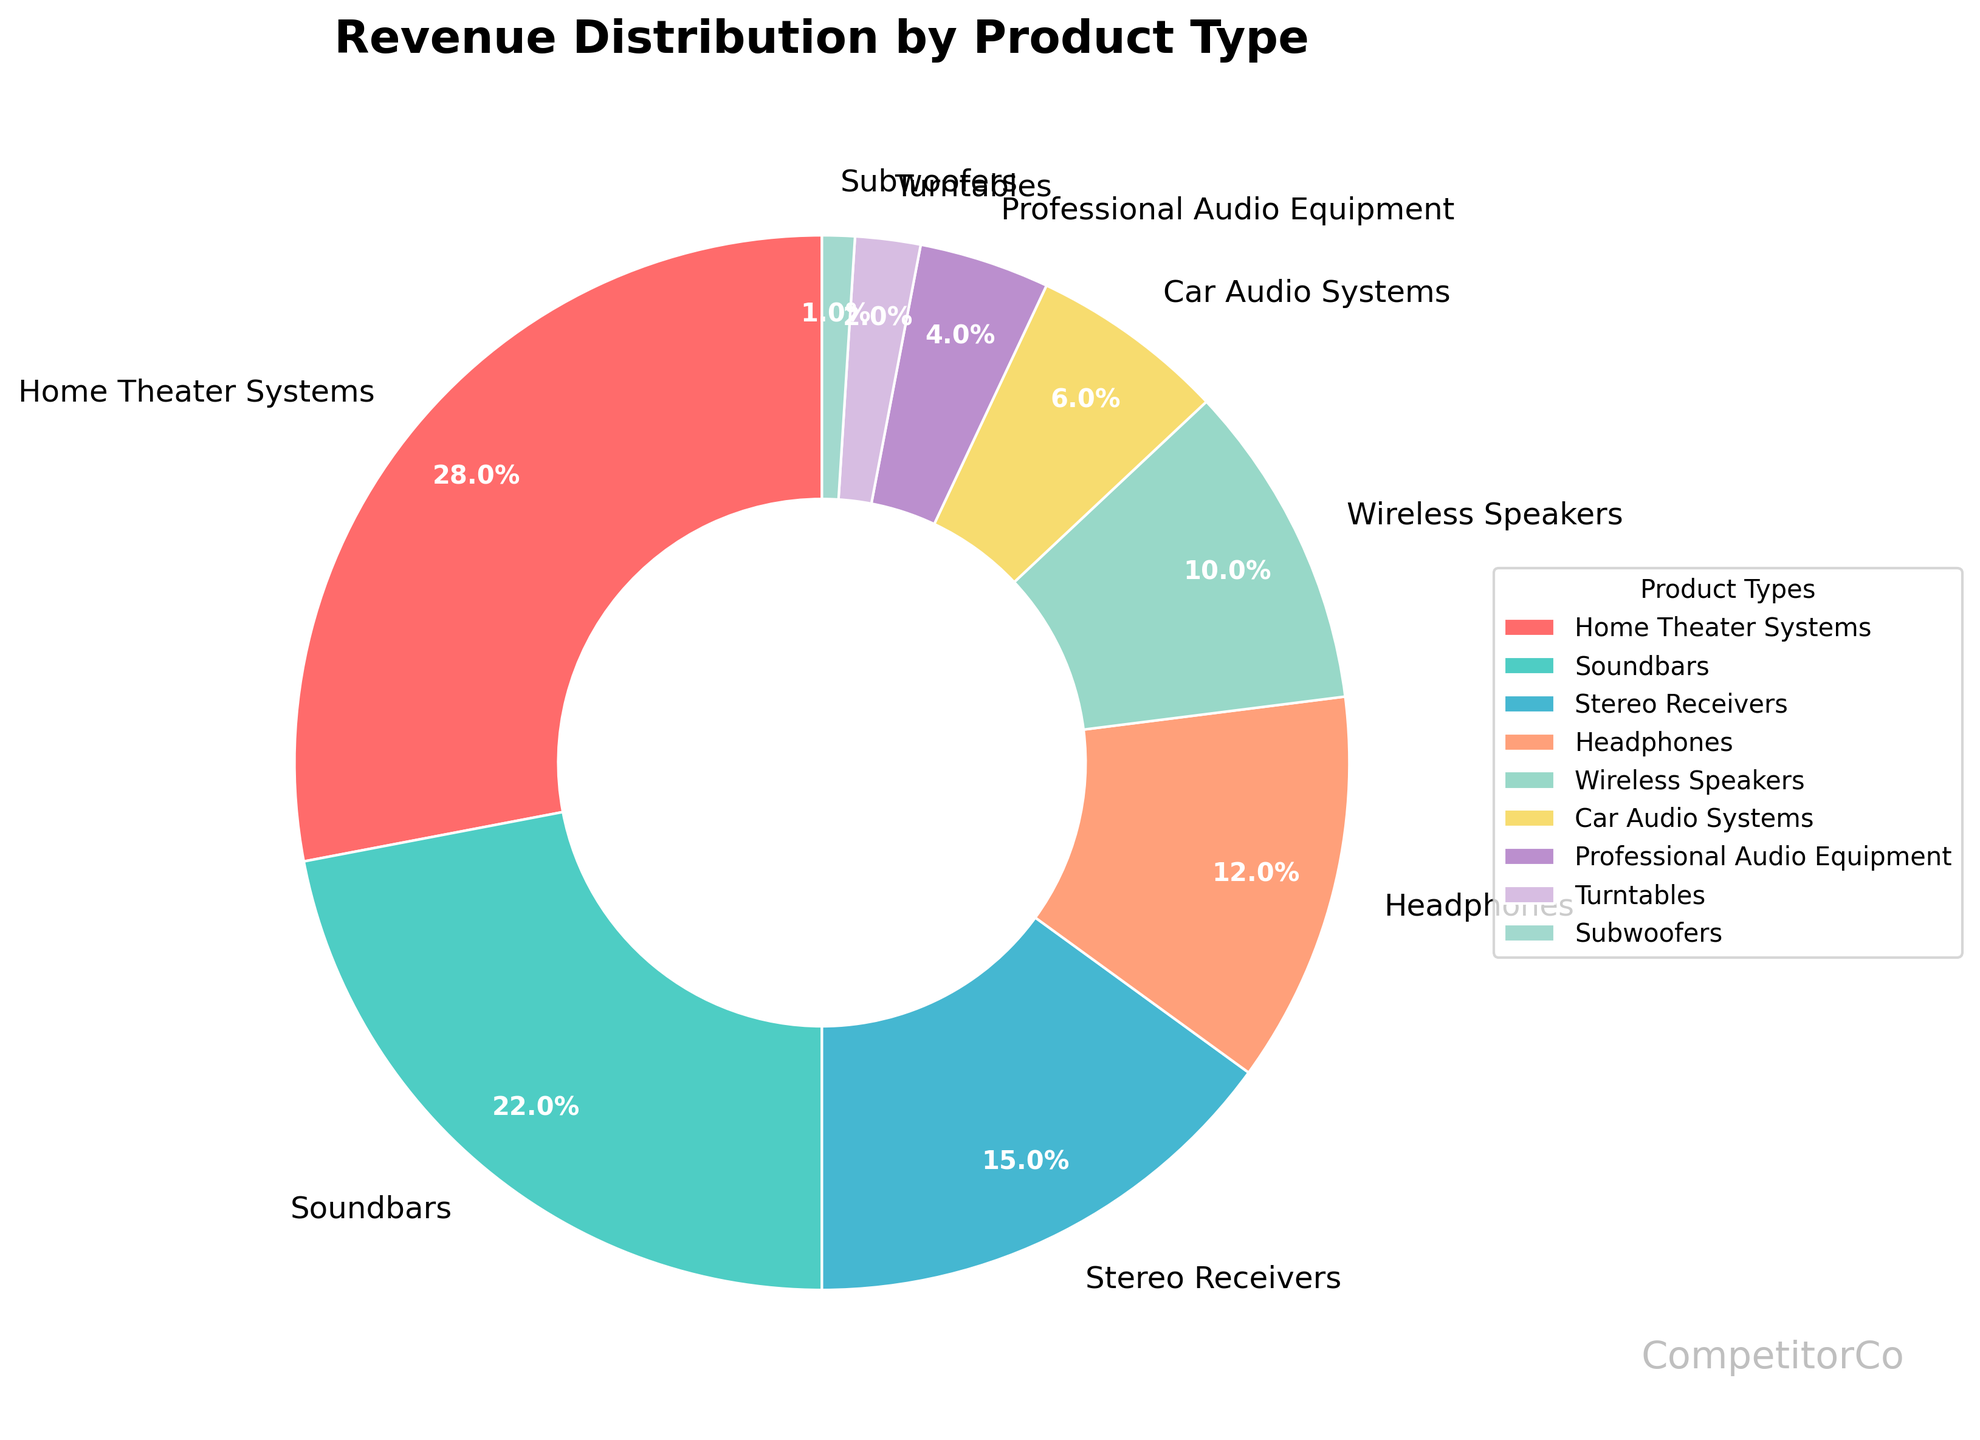What is the product type with the highest revenue percentage? Look at the slices of the pie chart and identify the largest slice. The largest slice corresponds to Home Theater Systems with a revenue percentage of 28%.
Answer: Home Theater Systems Which product type has a higher revenue percentage: Soundbars or Wireless Speakers? Compare the slices for Soundbars and Wireless Speakers. Soundbars have a revenue percentage of 22%, while Wireless Speakers have 10%. 22% is greater than 10%.
Answer: Soundbars What is the total revenue percentage for Home Theater Systems and Soundbars combined? Add the revenue percentages of Home Theater Systems (28%) and Soundbars (22%) together. 28 + 22 = 50.
Answer: 50% Which product types have a revenue percentage below 5%? Look at the slices and find those with a revenue percentage lower than 5%. These are Professional Audio Equipment (4%), Turntables (2%), and Subwoofers (1%).
Answer: Professional Audio Equipment, Turntables, Subwoofers What is the difference in revenue percentage between Stereo Receivers and Car Audio Systems? Subtract the revenue percentage of Car Audio Systems (6%) from Stereo Receivers (15%). 15 - 6 = 9.
Answer: 9% What color represents the Turntables slice? Observe the color of the slice labeled "Turntables." The Turntables slice is represented by a purple color.
Answer: Purple Which category contributes the least to the total revenue? Identify the smallest slice in the pie chart. The smallest slice corresponds to Subwoofers with a revenue percentage of 1%.
Answer: Subwoofers How does the revenue percentage for Headphones compare to Wireless Speakers? Compare the slices for Headphones and Wireless Speakers. Headphones have a revenue percentage of 12%, while Wireless Speakers have 10%. 12% is greater than 10%.
Answer: Headphones are higher What is the percentage difference in revenue between Professional Audio Equipment and Soundbars? Subtract the revenue percentage of Professional Audio Equipment (4%) from Soundbars (22%). 22 - 4 = 18.
Answer: 18% 